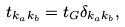Convert formula to latex. <formula><loc_0><loc_0><loc_500><loc_500>t _ { { k } _ { a } { k } _ { b } } = t _ { G } \delta _ { { k } _ { a } { k } _ { b } } ,</formula> 